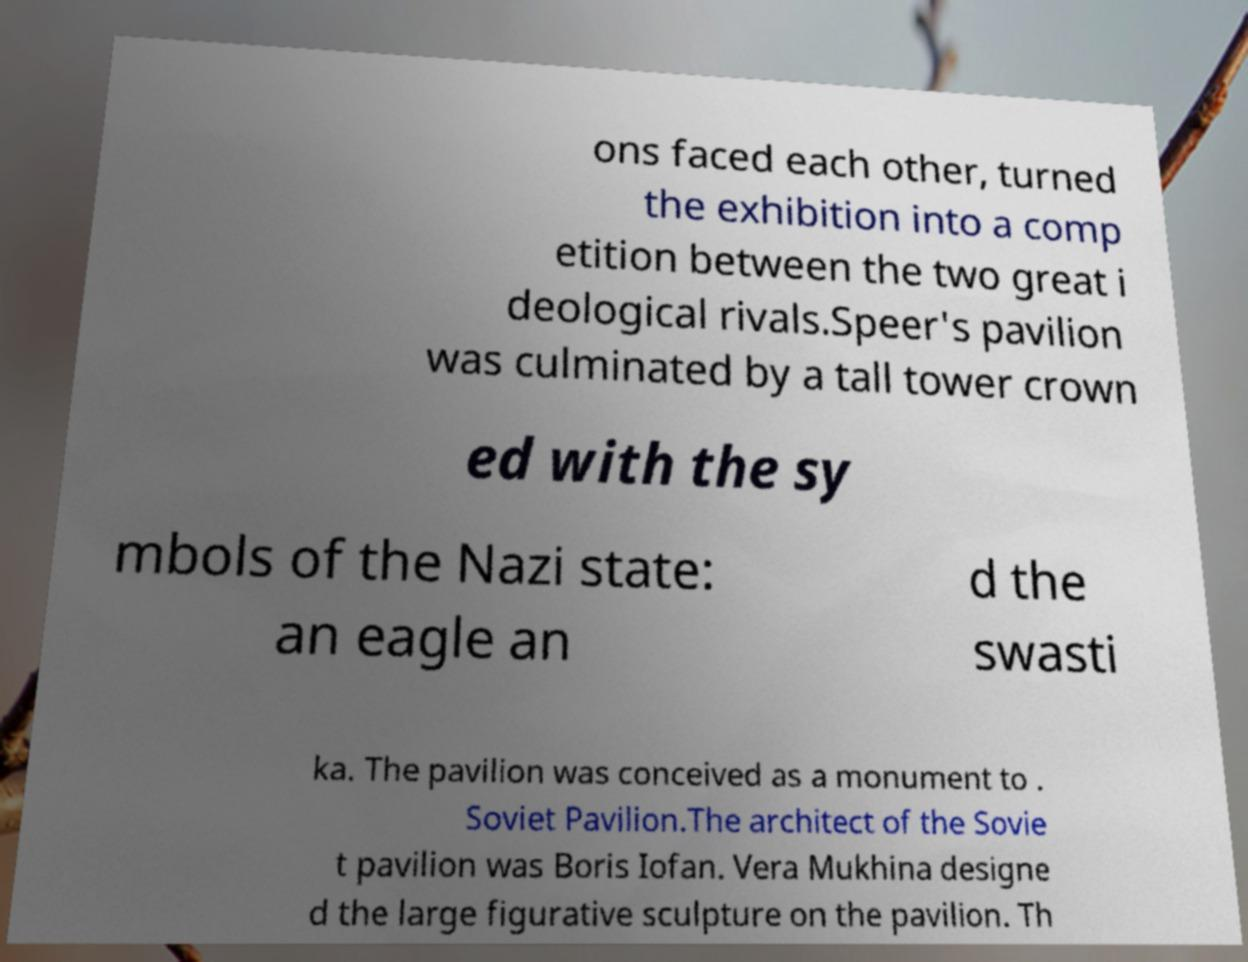I need the written content from this picture converted into text. Can you do that? ons faced each other, turned the exhibition into a comp etition between the two great i deological rivals.Speer's pavilion was culminated by a tall tower crown ed with the sy mbols of the Nazi state: an eagle an d the swasti ka. The pavilion was conceived as a monument to . Soviet Pavilion.The architect of the Sovie t pavilion was Boris Iofan. Vera Mukhina designe d the large figurative sculpture on the pavilion. Th 